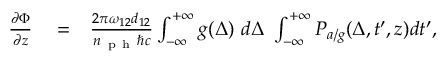Convert formula to latex. <formula><loc_0><loc_0><loc_500><loc_500>\begin{array} { r l r } { \frac { \partial \Phi } { \partial z } } & = } & { \frac { 2 \pi \omega _ { 1 2 } d _ { 1 2 } } { n _ { p h } \hbar { c } } \int _ { - \infty } ^ { + \infty } g ( \Delta ) \ d \Delta \ \int _ { - \infty } ^ { + \infty } P _ { a / g } ( \Delta , t ^ { \prime } , z ) d t ^ { \prime } , } \end{array}</formula> 